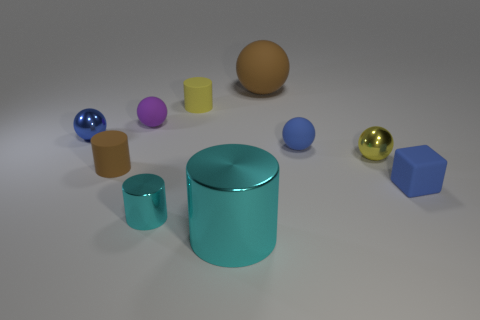Subtract all brown spheres. How many spheres are left? 4 Subtract all purple balls. How many balls are left? 4 Subtract all gray spheres. Subtract all gray cylinders. How many spheres are left? 5 Subtract all cylinders. How many objects are left? 6 Subtract 0 cyan balls. How many objects are left? 10 Subtract all red things. Subtract all blue spheres. How many objects are left? 8 Add 1 metallic cylinders. How many metallic cylinders are left? 3 Add 5 brown things. How many brown things exist? 7 